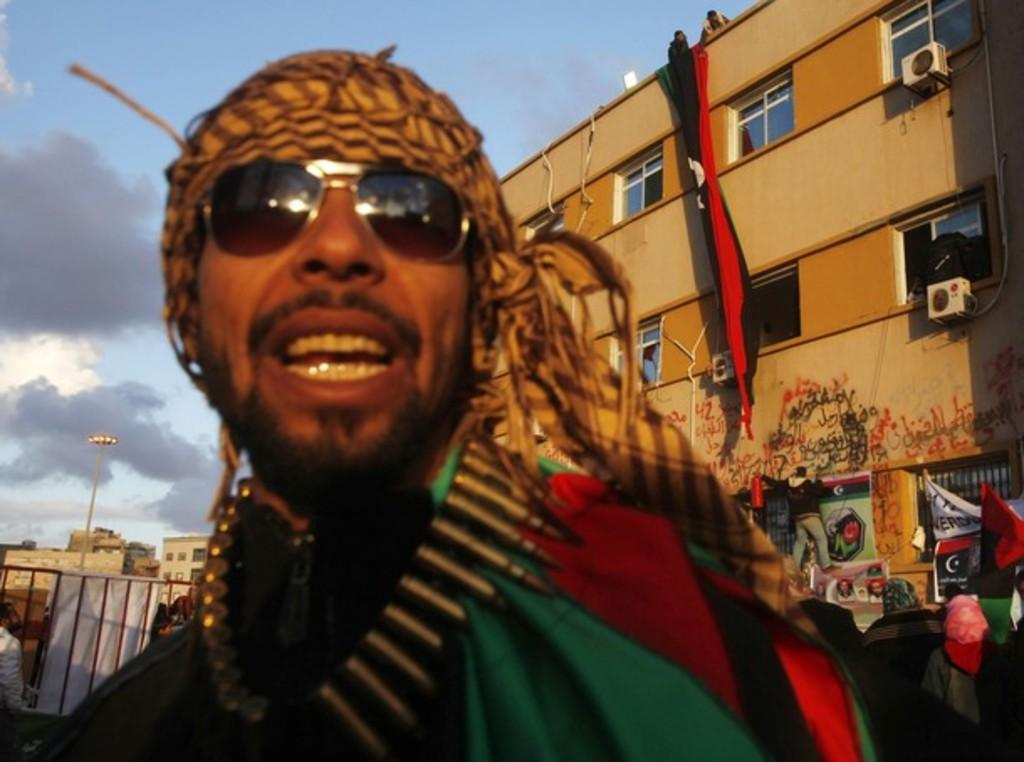What is the person in the image wearing on their face? The person in the image is wearing goggles. What can be seen in the distance behind the person? There are buildings, a light pole, banners, a grille, and people in the background of the image. What is the weather like in the image? The sky is cloudy in the background of the image, indicating a cloudy condition. What type of objects are present in the background of the image? There are objects in the background of the image, including buildings, a light pole, banners, a grille, and people. What type of sweater is the person wearing in the image? There is no sweater visible in the image; the person is wearing goggles. How many eggs are present in the image? There are no eggs present in the image. 